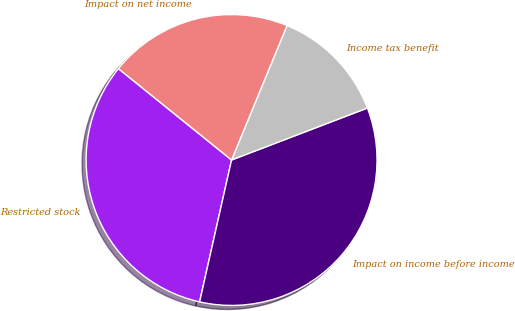Convert chart to OTSL. <chart><loc_0><loc_0><loc_500><loc_500><pie_chart><fcel>Restricted stock<fcel>Impact on income before income<fcel>Income tax benefit<fcel>Impact on net income<nl><fcel>32.29%<fcel>34.34%<fcel>12.96%<fcel>20.41%<nl></chart> 